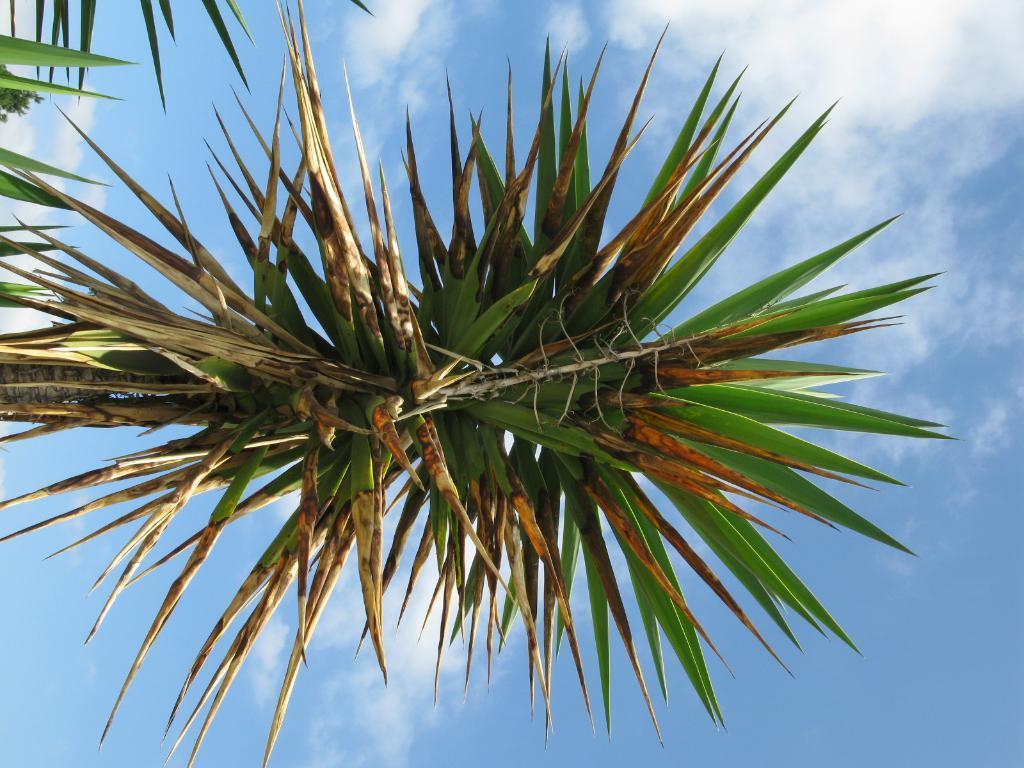How would you summarize this image in a sentence or two? In this image we can see one big tree, some leaves, one small tree and background there is the sky. 